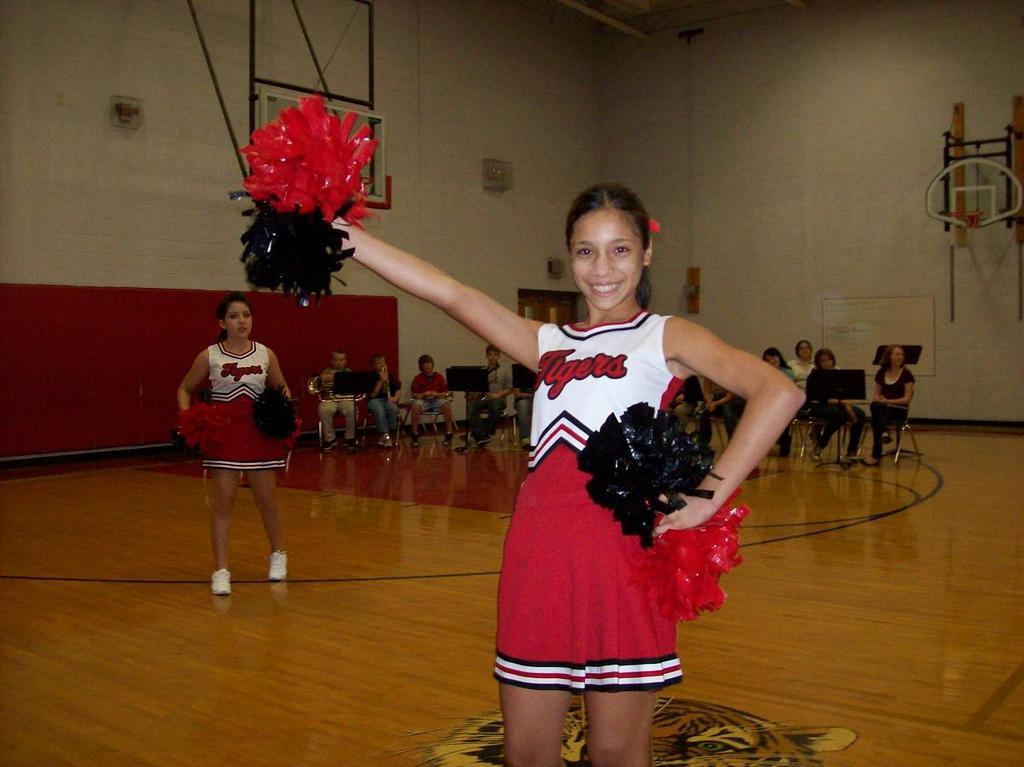<image>
Present a compact description of the photo's key features. Tigers cheerleaders practice in their red, black, and white uniforms. 